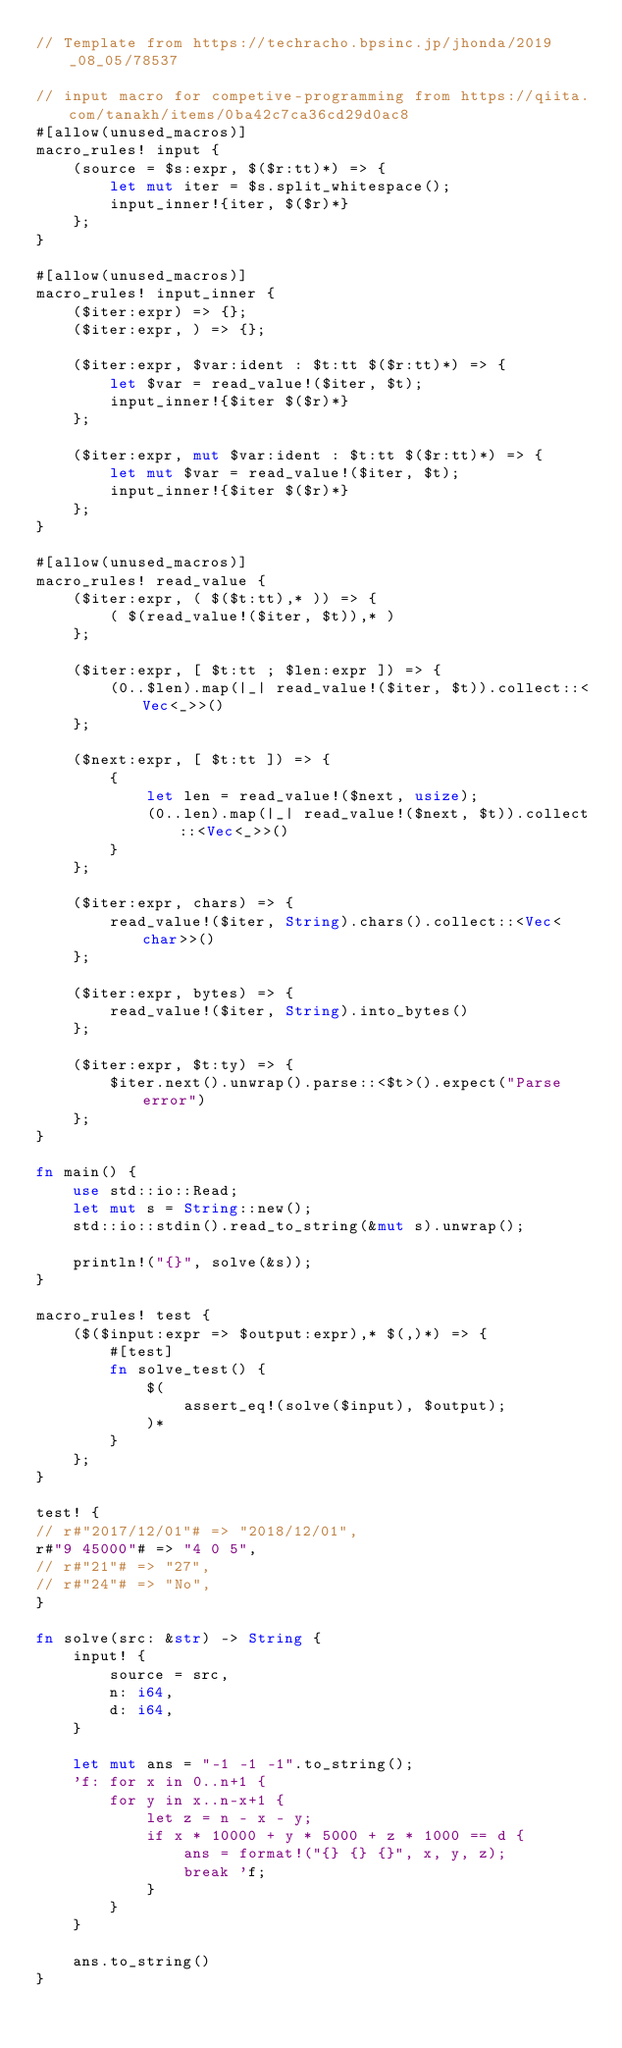<code> <loc_0><loc_0><loc_500><loc_500><_Rust_>// Template from https://techracho.bpsinc.jp/jhonda/2019_08_05/78537

// input macro for competive-programming from https://qiita.com/tanakh/items/0ba42c7ca36cd29d0ac8
#[allow(unused_macros)]
macro_rules! input {
    (source = $s:expr, $($r:tt)*) => {
        let mut iter = $s.split_whitespace();
        input_inner!{iter, $($r)*}
    };
}

#[allow(unused_macros)]
macro_rules! input_inner {
    ($iter:expr) => {};
    ($iter:expr, ) => {};

    ($iter:expr, $var:ident : $t:tt $($r:tt)*) => {
        let $var = read_value!($iter, $t);
        input_inner!{$iter $($r)*}
    };

    ($iter:expr, mut $var:ident : $t:tt $($r:tt)*) => {
        let mut $var = read_value!($iter, $t);
        input_inner!{$iter $($r)*}
    };
}

#[allow(unused_macros)]
macro_rules! read_value {
    ($iter:expr, ( $($t:tt),* )) => {
        ( $(read_value!($iter, $t)),* )
    };

    ($iter:expr, [ $t:tt ; $len:expr ]) => {
        (0..$len).map(|_| read_value!($iter, $t)).collect::<Vec<_>>()
    };

    ($next:expr, [ $t:tt ]) => {
        {
            let len = read_value!($next, usize);
            (0..len).map(|_| read_value!($next, $t)).collect::<Vec<_>>()
        }
    };

    ($iter:expr, chars) => {
        read_value!($iter, String).chars().collect::<Vec<char>>()
    };

    ($iter:expr, bytes) => {
        read_value!($iter, String).into_bytes()
    };

    ($iter:expr, $t:ty) => {
        $iter.next().unwrap().parse::<$t>().expect("Parse error")
    };
}

fn main() {
    use std::io::Read;
    let mut s = String::new();
    std::io::stdin().read_to_string(&mut s).unwrap();

    println!("{}", solve(&s));
}

macro_rules! test {
    ($($input:expr => $output:expr),* $(,)*) => {
        #[test]
        fn solve_test() {
            $(
                assert_eq!(solve($input), $output);
            )*
        }
    };
}

test! {
// r#"2017/12/01"# => "2018/12/01",
r#"9 45000"# => "4 0 5",
// r#"21"# => "27",
// r#"24"# => "No",
}

fn solve(src: &str) -> String {
    input! {
        source = src,
        n: i64,
        d: i64,
    }

    let mut ans = "-1 -1 -1".to_string();
    'f: for x in 0..n+1 {
        for y in x..n-x+1 {
            let z = n - x - y;
            if x * 10000 + y * 5000 + z * 1000 == d {
                ans = format!("{} {} {}", x, y, z);
                break 'f;
            }
        }
    }

    ans.to_string()
}</code> 